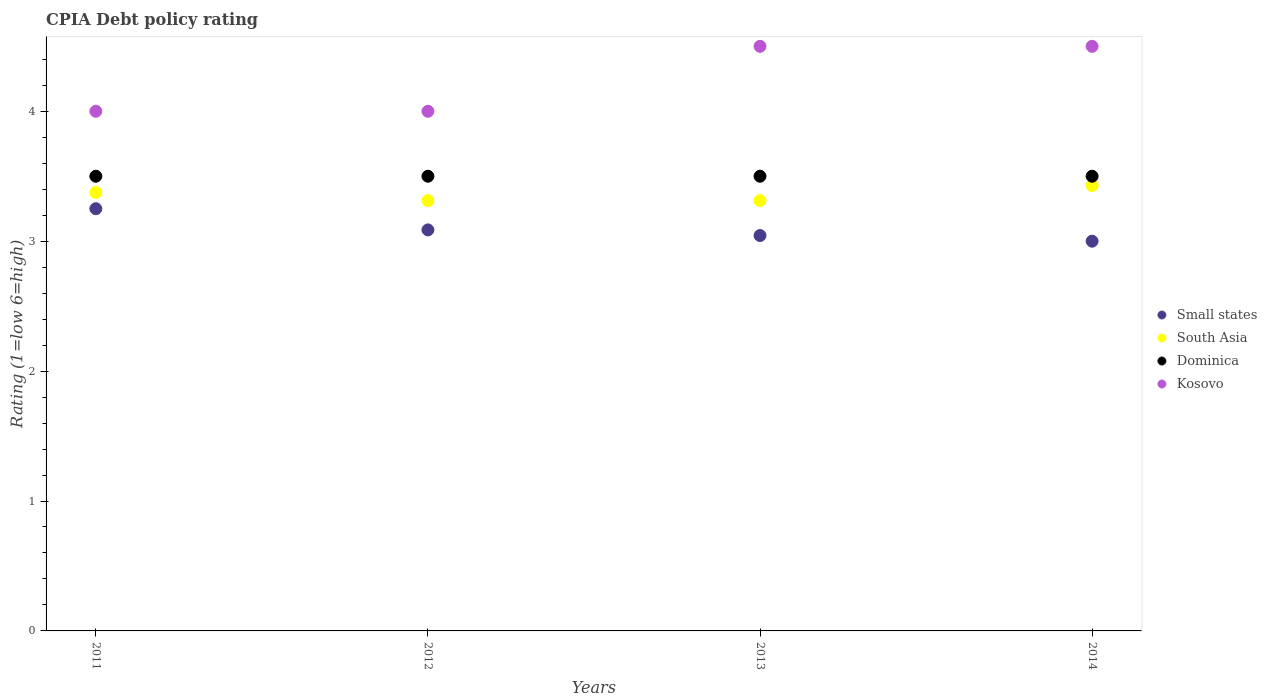Is the number of dotlines equal to the number of legend labels?
Ensure brevity in your answer.  Yes. Across all years, what is the maximum CPIA rating in South Asia?
Give a very brief answer. 3.43. Across all years, what is the minimum CPIA rating in Dominica?
Your answer should be very brief. 3.5. In which year was the CPIA rating in Small states maximum?
Your answer should be compact. 2011. What is the total CPIA rating in Small states in the graph?
Ensure brevity in your answer.  12.38. What is the difference between the CPIA rating in Dominica in 2012 and that in 2013?
Give a very brief answer. 0. What is the difference between the CPIA rating in South Asia in 2014 and the CPIA rating in Kosovo in 2012?
Your answer should be very brief. -0.57. What is the average CPIA rating in Small states per year?
Provide a succinct answer. 3.1. In how many years, is the CPIA rating in South Asia greater than 3?
Keep it short and to the point. 4. What is the difference between the highest and the second highest CPIA rating in Dominica?
Offer a very short reply. 0. What is the difference between the highest and the lowest CPIA rating in Dominica?
Your response must be concise. 0. Is the sum of the CPIA rating in Small states in 2011 and 2012 greater than the maximum CPIA rating in Dominica across all years?
Your response must be concise. Yes. Is it the case that in every year, the sum of the CPIA rating in Dominica and CPIA rating in South Asia  is greater than the sum of CPIA rating in Small states and CPIA rating in Kosovo?
Offer a terse response. No. Is the CPIA rating in Kosovo strictly greater than the CPIA rating in South Asia over the years?
Give a very brief answer. Yes. Is the CPIA rating in Dominica strictly less than the CPIA rating in Small states over the years?
Keep it short and to the point. No. How many dotlines are there?
Make the answer very short. 4. Are the values on the major ticks of Y-axis written in scientific E-notation?
Offer a very short reply. No. Where does the legend appear in the graph?
Give a very brief answer. Center right. What is the title of the graph?
Make the answer very short. CPIA Debt policy rating. Does "Chad" appear as one of the legend labels in the graph?
Keep it short and to the point. No. What is the label or title of the Y-axis?
Your answer should be compact. Rating (1=low 6=high). What is the Rating (1=low 6=high) in Small states in 2011?
Your response must be concise. 3.25. What is the Rating (1=low 6=high) in South Asia in 2011?
Your answer should be compact. 3.38. What is the Rating (1=low 6=high) of Dominica in 2011?
Make the answer very short. 3.5. What is the Rating (1=low 6=high) in Kosovo in 2011?
Offer a terse response. 4. What is the Rating (1=low 6=high) of Small states in 2012?
Offer a very short reply. 3.09. What is the Rating (1=low 6=high) in South Asia in 2012?
Offer a terse response. 3.31. What is the Rating (1=low 6=high) in Dominica in 2012?
Give a very brief answer. 3.5. What is the Rating (1=low 6=high) in Small states in 2013?
Make the answer very short. 3.04. What is the Rating (1=low 6=high) in South Asia in 2013?
Provide a short and direct response. 3.31. What is the Rating (1=low 6=high) of South Asia in 2014?
Offer a terse response. 3.43. What is the Rating (1=low 6=high) of Dominica in 2014?
Keep it short and to the point. 3.5. Across all years, what is the maximum Rating (1=low 6=high) of Small states?
Ensure brevity in your answer.  3.25. Across all years, what is the maximum Rating (1=low 6=high) of South Asia?
Provide a succinct answer. 3.43. Across all years, what is the maximum Rating (1=low 6=high) in Dominica?
Keep it short and to the point. 3.5. Across all years, what is the minimum Rating (1=low 6=high) in Small states?
Offer a very short reply. 3. Across all years, what is the minimum Rating (1=low 6=high) in South Asia?
Give a very brief answer. 3.31. Across all years, what is the minimum Rating (1=low 6=high) in Dominica?
Your answer should be very brief. 3.5. Across all years, what is the minimum Rating (1=low 6=high) of Kosovo?
Ensure brevity in your answer.  4. What is the total Rating (1=low 6=high) in Small states in the graph?
Give a very brief answer. 12.38. What is the total Rating (1=low 6=high) in South Asia in the graph?
Provide a succinct answer. 13.43. What is the total Rating (1=low 6=high) in Kosovo in the graph?
Your response must be concise. 17. What is the difference between the Rating (1=low 6=high) in Small states in 2011 and that in 2012?
Make the answer very short. 0.16. What is the difference between the Rating (1=low 6=high) of South Asia in 2011 and that in 2012?
Offer a very short reply. 0.06. What is the difference between the Rating (1=low 6=high) of Kosovo in 2011 and that in 2012?
Provide a short and direct response. 0. What is the difference between the Rating (1=low 6=high) of Small states in 2011 and that in 2013?
Your answer should be compact. 0.21. What is the difference between the Rating (1=low 6=high) of South Asia in 2011 and that in 2013?
Your answer should be compact. 0.06. What is the difference between the Rating (1=low 6=high) of Kosovo in 2011 and that in 2013?
Your answer should be compact. -0.5. What is the difference between the Rating (1=low 6=high) in South Asia in 2011 and that in 2014?
Your answer should be very brief. -0.05. What is the difference between the Rating (1=low 6=high) of Dominica in 2011 and that in 2014?
Ensure brevity in your answer.  0. What is the difference between the Rating (1=low 6=high) in Kosovo in 2011 and that in 2014?
Provide a succinct answer. -0.5. What is the difference between the Rating (1=low 6=high) of Small states in 2012 and that in 2013?
Make the answer very short. 0.04. What is the difference between the Rating (1=low 6=high) in South Asia in 2012 and that in 2013?
Ensure brevity in your answer.  0. What is the difference between the Rating (1=low 6=high) in Kosovo in 2012 and that in 2013?
Your response must be concise. -0.5. What is the difference between the Rating (1=low 6=high) of Small states in 2012 and that in 2014?
Offer a very short reply. 0.09. What is the difference between the Rating (1=low 6=high) in South Asia in 2012 and that in 2014?
Provide a succinct answer. -0.12. What is the difference between the Rating (1=low 6=high) in Small states in 2013 and that in 2014?
Your answer should be compact. 0.04. What is the difference between the Rating (1=low 6=high) in South Asia in 2013 and that in 2014?
Offer a very short reply. -0.12. What is the difference between the Rating (1=low 6=high) of Dominica in 2013 and that in 2014?
Your answer should be very brief. 0. What is the difference between the Rating (1=low 6=high) of Small states in 2011 and the Rating (1=low 6=high) of South Asia in 2012?
Keep it short and to the point. -0.06. What is the difference between the Rating (1=low 6=high) of Small states in 2011 and the Rating (1=low 6=high) of Dominica in 2012?
Provide a short and direct response. -0.25. What is the difference between the Rating (1=low 6=high) in Small states in 2011 and the Rating (1=low 6=high) in Kosovo in 2012?
Provide a succinct answer. -0.75. What is the difference between the Rating (1=low 6=high) of South Asia in 2011 and the Rating (1=low 6=high) of Dominica in 2012?
Provide a short and direct response. -0.12. What is the difference between the Rating (1=low 6=high) of South Asia in 2011 and the Rating (1=low 6=high) of Kosovo in 2012?
Provide a short and direct response. -0.62. What is the difference between the Rating (1=low 6=high) of Dominica in 2011 and the Rating (1=low 6=high) of Kosovo in 2012?
Make the answer very short. -0.5. What is the difference between the Rating (1=low 6=high) in Small states in 2011 and the Rating (1=low 6=high) in South Asia in 2013?
Make the answer very short. -0.06. What is the difference between the Rating (1=low 6=high) in Small states in 2011 and the Rating (1=low 6=high) in Kosovo in 2013?
Your answer should be compact. -1.25. What is the difference between the Rating (1=low 6=high) of South Asia in 2011 and the Rating (1=low 6=high) of Dominica in 2013?
Offer a very short reply. -0.12. What is the difference between the Rating (1=low 6=high) in South Asia in 2011 and the Rating (1=low 6=high) in Kosovo in 2013?
Your answer should be compact. -1.12. What is the difference between the Rating (1=low 6=high) in Small states in 2011 and the Rating (1=low 6=high) in South Asia in 2014?
Give a very brief answer. -0.18. What is the difference between the Rating (1=low 6=high) of Small states in 2011 and the Rating (1=low 6=high) of Kosovo in 2014?
Offer a terse response. -1.25. What is the difference between the Rating (1=low 6=high) of South Asia in 2011 and the Rating (1=low 6=high) of Dominica in 2014?
Your answer should be compact. -0.12. What is the difference between the Rating (1=low 6=high) in South Asia in 2011 and the Rating (1=low 6=high) in Kosovo in 2014?
Offer a very short reply. -1.12. What is the difference between the Rating (1=low 6=high) of Small states in 2012 and the Rating (1=low 6=high) of South Asia in 2013?
Ensure brevity in your answer.  -0.23. What is the difference between the Rating (1=low 6=high) of Small states in 2012 and the Rating (1=low 6=high) of Dominica in 2013?
Provide a short and direct response. -0.41. What is the difference between the Rating (1=low 6=high) in Small states in 2012 and the Rating (1=low 6=high) in Kosovo in 2013?
Provide a short and direct response. -1.41. What is the difference between the Rating (1=low 6=high) in South Asia in 2012 and the Rating (1=low 6=high) in Dominica in 2013?
Provide a succinct answer. -0.19. What is the difference between the Rating (1=low 6=high) in South Asia in 2012 and the Rating (1=low 6=high) in Kosovo in 2013?
Make the answer very short. -1.19. What is the difference between the Rating (1=low 6=high) in Small states in 2012 and the Rating (1=low 6=high) in South Asia in 2014?
Give a very brief answer. -0.34. What is the difference between the Rating (1=low 6=high) in Small states in 2012 and the Rating (1=low 6=high) in Dominica in 2014?
Your answer should be very brief. -0.41. What is the difference between the Rating (1=low 6=high) in Small states in 2012 and the Rating (1=low 6=high) in Kosovo in 2014?
Offer a terse response. -1.41. What is the difference between the Rating (1=low 6=high) of South Asia in 2012 and the Rating (1=low 6=high) of Dominica in 2014?
Your answer should be very brief. -0.19. What is the difference between the Rating (1=low 6=high) of South Asia in 2012 and the Rating (1=low 6=high) of Kosovo in 2014?
Offer a very short reply. -1.19. What is the difference between the Rating (1=low 6=high) in Dominica in 2012 and the Rating (1=low 6=high) in Kosovo in 2014?
Your answer should be very brief. -1. What is the difference between the Rating (1=low 6=high) of Small states in 2013 and the Rating (1=low 6=high) of South Asia in 2014?
Give a very brief answer. -0.39. What is the difference between the Rating (1=low 6=high) of Small states in 2013 and the Rating (1=low 6=high) of Dominica in 2014?
Offer a terse response. -0.46. What is the difference between the Rating (1=low 6=high) of Small states in 2013 and the Rating (1=low 6=high) of Kosovo in 2014?
Ensure brevity in your answer.  -1.46. What is the difference between the Rating (1=low 6=high) in South Asia in 2013 and the Rating (1=low 6=high) in Dominica in 2014?
Your response must be concise. -0.19. What is the difference between the Rating (1=low 6=high) in South Asia in 2013 and the Rating (1=low 6=high) in Kosovo in 2014?
Make the answer very short. -1.19. What is the difference between the Rating (1=low 6=high) of Dominica in 2013 and the Rating (1=low 6=high) of Kosovo in 2014?
Your answer should be very brief. -1. What is the average Rating (1=low 6=high) of Small states per year?
Provide a short and direct response. 3.1. What is the average Rating (1=low 6=high) of South Asia per year?
Provide a short and direct response. 3.36. What is the average Rating (1=low 6=high) in Kosovo per year?
Offer a terse response. 4.25. In the year 2011, what is the difference between the Rating (1=low 6=high) of Small states and Rating (1=low 6=high) of South Asia?
Your response must be concise. -0.12. In the year 2011, what is the difference between the Rating (1=low 6=high) of Small states and Rating (1=low 6=high) of Dominica?
Offer a terse response. -0.25. In the year 2011, what is the difference between the Rating (1=low 6=high) of Small states and Rating (1=low 6=high) of Kosovo?
Provide a succinct answer. -0.75. In the year 2011, what is the difference between the Rating (1=low 6=high) in South Asia and Rating (1=low 6=high) in Dominica?
Your answer should be very brief. -0.12. In the year 2011, what is the difference between the Rating (1=low 6=high) in South Asia and Rating (1=low 6=high) in Kosovo?
Provide a short and direct response. -0.62. In the year 2012, what is the difference between the Rating (1=low 6=high) of Small states and Rating (1=low 6=high) of South Asia?
Keep it short and to the point. -0.23. In the year 2012, what is the difference between the Rating (1=low 6=high) in Small states and Rating (1=low 6=high) in Dominica?
Provide a succinct answer. -0.41. In the year 2012, what is the difference between the Rating (1=low 6=high) of Small states and Rating (1=low 6=high) of Kosovo?
Ensure brevity in your answer.  -0.91. In the year 2012, what is the difference between the Rating (1=low 6=high) of South Asia and Rating (1=low 6=high) of Dominica?
Your response must be concise. -0.19. In the year 2012, what is the difference between the Rating (1=low 6=high) in South Asia and Rating (1=low 6=high) in Kosovo?
Offer a terse response. -0.69. In the year 2012, what is the difference between the Rating (1=low 6=high) in Dominica and Rating (1=low 6=high) in Kosovo?
Offer a very short reply. -0.5. In the year 2013, what is the difference between the Rating (1=low 6=high) in Small states and Rating (1=low 6=high) in South Asia?
Give a very brief answer. -0.27. In the year 2013, what is the difference between the Rating (1=low 6=high) in Small states and Rating (1=low 6=high) in Dominica?
Your response must be concise. -0.46. In the year 2013, what is the difference between the Rating (1=low 6=high) in Small states and Rating (1=low 6=high) in Kosovo?
Your response must be concise. -1.46. In the year 2013, what is the difference between the Rating (1=low 6=high) in South Asia and Rating (1=low 6=high) in Dominica?
Your answer should be very brief. -0.19. In the year 2013, what is the difference between the Rating (1=low 6=high) of South Asia and Rating (1=low 6=high) of Kosovo?
Make the answer very short. -1.19. In the year 2014, what is the difference between the Rating (1=low 6=high) of Small states and Rating (1=low 6=high) of South Asia?
Offer a very short reply. -0.43. In the year 2014, what is the difference between the Rating (1=low 6=high) in South Asia and Rating (1=low 6=high) in Dominica?
Your response must be concise. -0.07. In the year 2014, what is the difference between the Rating (1=low 6=high) in South Asia and Rating (1=low 6=high) in Kosovo?
Keep it short and to the point. -1.07. In the year 2014, what is the difference between the Rating (1=low 6=high) of Dominica and Rating (1=low 6=high) of Kosovo?
Your response must be concise. -1. What is the ratio of the Rating (1=low 6=high) in Small states in 2011 to that in 2012?
Provide a short and direct response. 1.05. What is the ratio of the Rating (1=low 6=high) in South Asia in 2011 to that in 2012?
Provide a succinct answer. 1.02. What is the ratio of the Rating (1=low 6=high) in Dominica in 2011 to that in 2012?
Your answer should be very brief. 1. What is the ratio of the Rating (1=low 6=high) in Kosovo in 2011 to that in 2012?
Your response must be concise. 1. What is the ratio of the Rating (1=low 6=high) of Small states in 2011 to that in 2013?
Your answer should be compact. 1.07. What is the ratio of the Rating (1=low 6=high) in South Asia in 2011 to that in 2013?
Offer a terse response. 1.02. What is the ratio of the Rating (1=low 6=high) of Dominica in 2011 to that in 2013?
Offer a very short reply. 1. What is the ratio of the Rating (1=low 6=high) of South Asia in 2011 to that in 2014?
Keep it short and to the point. 0.98. What is the ratio of the Rating (1=low 6=high) in Dominica in 2011 to that in 2014?
Provide a succinct answer. 1. What is the ratio of the Rating (1=low 6=high) of Kosovo in 2011 to that in 2014?
Your response must be concise. 0.89. What is the ratio of the Rating (1=low 6=high) in Small states in 2012 to that in 2013?
Provide a short and direct response. 1.01. What is the ratio of the Rating (1=low 6=high) in Dominica in 2012 to that in 2013?
Offer a very short reply. 1. What is the ratio of the Rating (1=low 6=high) in Small states in 2012 to that in 2014?
Keep it short and to the point. 1.03. What is the ratio of the Rating (1=low 6=high) in South Asia in 2012 to that in 2014?
Your answer should be very brief. 0.97. What is the ratio of the Rating (1=low 6=high) of Dominica in 2012 to that in 2014?
Give a very brief answer. 1. What is the ratio of the Rating (1=low 6=high) in Small states in 2013 to that in 2014?
Your answer should be very brief. 1.01. What is the ratio of the Rating (1=low 6=high) in South Asia in 2013 to that in 2014?
Give a very brief answer. 0.97. What is the difference between the highest and the second highest Rating (1=low 6=high) of Small states?
Your response must be concise. 0.16. What is the difference between the highest and the second highest Rating (1=low 6=high) of South Asia?
Your answer should be compact. 0.05. What is the difference between the highest and the lowest Rating (1=low 6=high) in South Asia?
Ensure brevity in your answer.  0.12. 